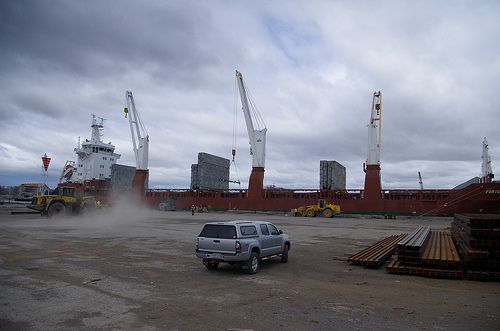<image>
Is there a car in the road? Yes. The car is contained within or inside the road, showing a containment relationship. 